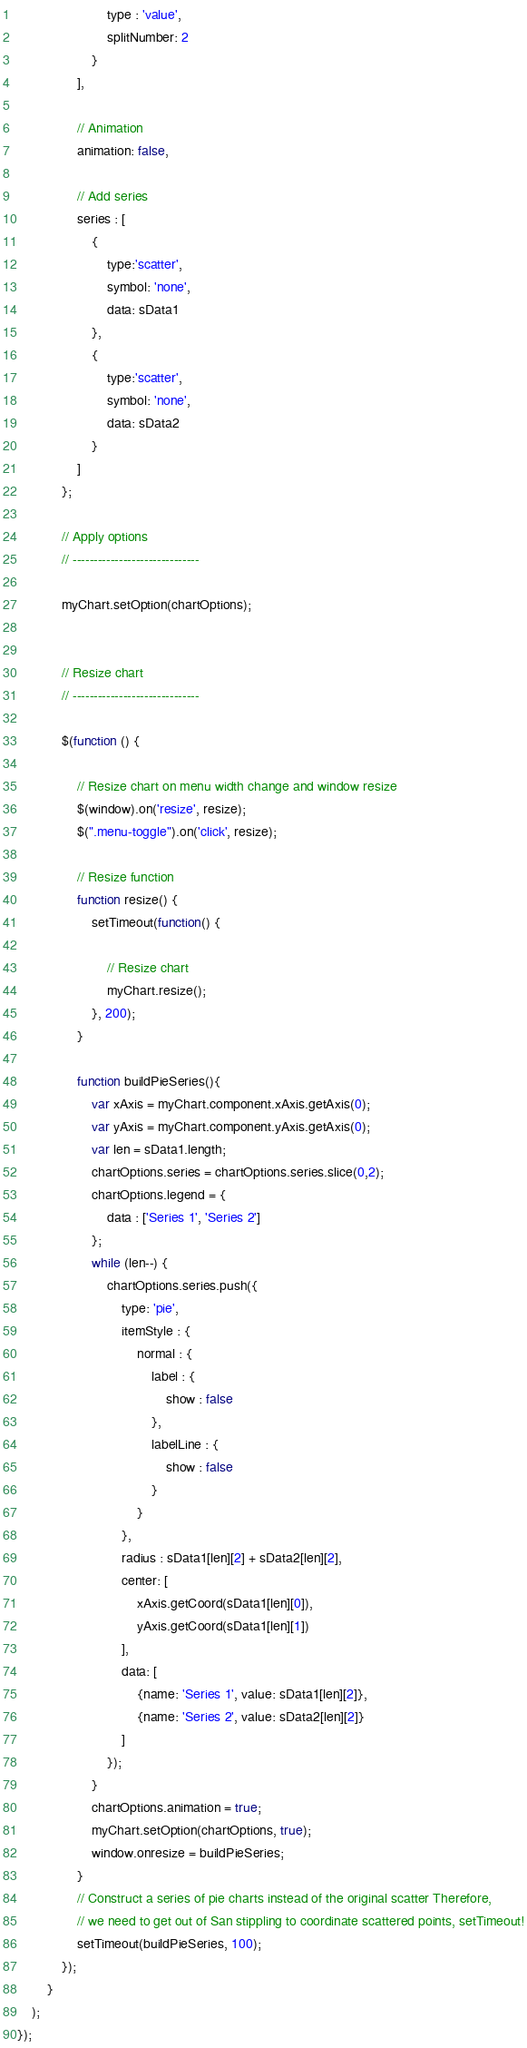<code> <loc_0><loc_0><loc_500><loc_500><_JavaScript_>                        type : 'value',
                        splitNumber: 2
                    }
                ],

                // Animation
                animation: false,

                // Add series
                series : [
                    {
                        type:'scatter',
                        symbol: 'none',
                        data: sData1
                    },
                    {
                        type:'scatter',
                        symbol: 'none',
                        data: sData2
                    }
                ]
            };

            // Apply options
            // ------------------------------

            myChart.setOption(chartOptions);


            // Resize chart
            // ------------------------------

            $(function () {

                // Resize chart on menu width change and window resize
                $(window).on('resize', resize);
                $(".menu-toggle").on('click', resize);

                // Resize function
                function resize() {
                    setTimeout(function() {

                        // Resize chart
                        myChart.resize();
                    }, 200);
                }

                function buildPieSeries(){
                    var xAxis = myChart.component.xAxis.getAxis(0);
                    var yAxis = myChart.component.yAxis.getAxis(0);
                    var len = sData1.length;
                    chartOptions.series = chartOptions.series.slice(0,2);
                    chartOptions.legend = {
                        data : ['Series 1', 'Series 2']
                    };
                    while (len--) {
                        chartOptions.series.push({
                            type: 'pie',
                            itemStyle : {
                                normal : {
                                    label : {
                                        show : false
                                    },
                                    labelLine : {
                                        show : false
                                    }
                                }
                            },
                            radius : sData1[len][2] + sData2[len][2],
                            center: [
                                xAxis.getCoord(sData1[len][0]),
                                yAxis.getCoord(sData1[len][1])
                            ],
                            data: [
                                {name: 'Series 1', value: sData1[len][2]},
                                {name: 'Series 2', value: sData2[len][2]}
                            ]
                        });
                    }
                    chartOptions.animation = true;
                    myChart.setOption(chartOptions, true);
                    window.onresize = buildPieSeries;
                }
                // Construct a series of pie charts instead of the original scatter Therefore,
                // we need to get out of San stippling to coordinate scattered points, setTimeout!
                setTimeout(buildPieSeries, 100);
            });
        }
    );
});</code> 